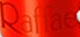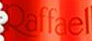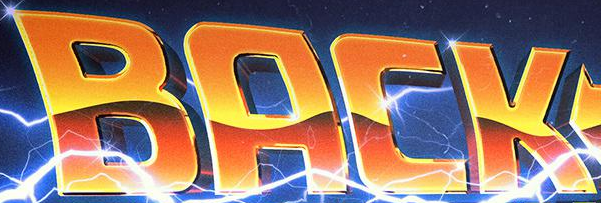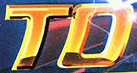Read the text from these images in sequence, separated by a semicolon. Raffae; Raffael; BACK; TO 